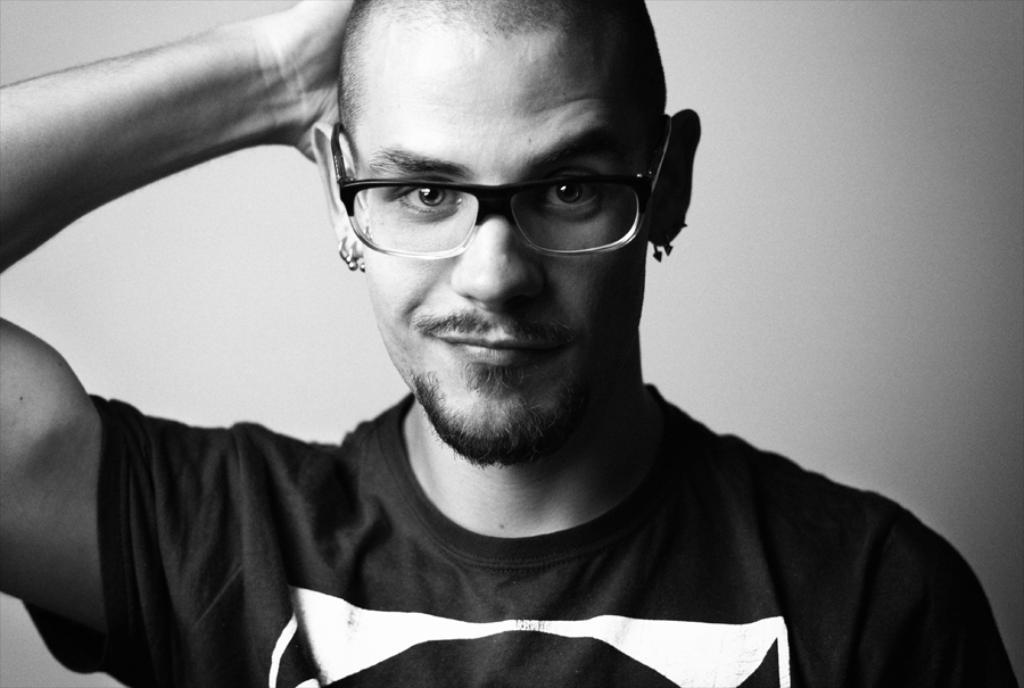What is the main subject of the image? The main subject of the image is a man. What type of clothing is the man wearing? The man is wearing a t-shirt. What accessory is the man wearing on his face? The man is wearing spectacles. What type of jewelry is the man wearing? The man is wearing earrings. What type of map can be seen in the man's hand in the image? There is no map present in the image; the man is not holding anything in his hand. What type of fiction book is the man reading in the image? There is no book present in the image, and the man is not shown reading anything. 